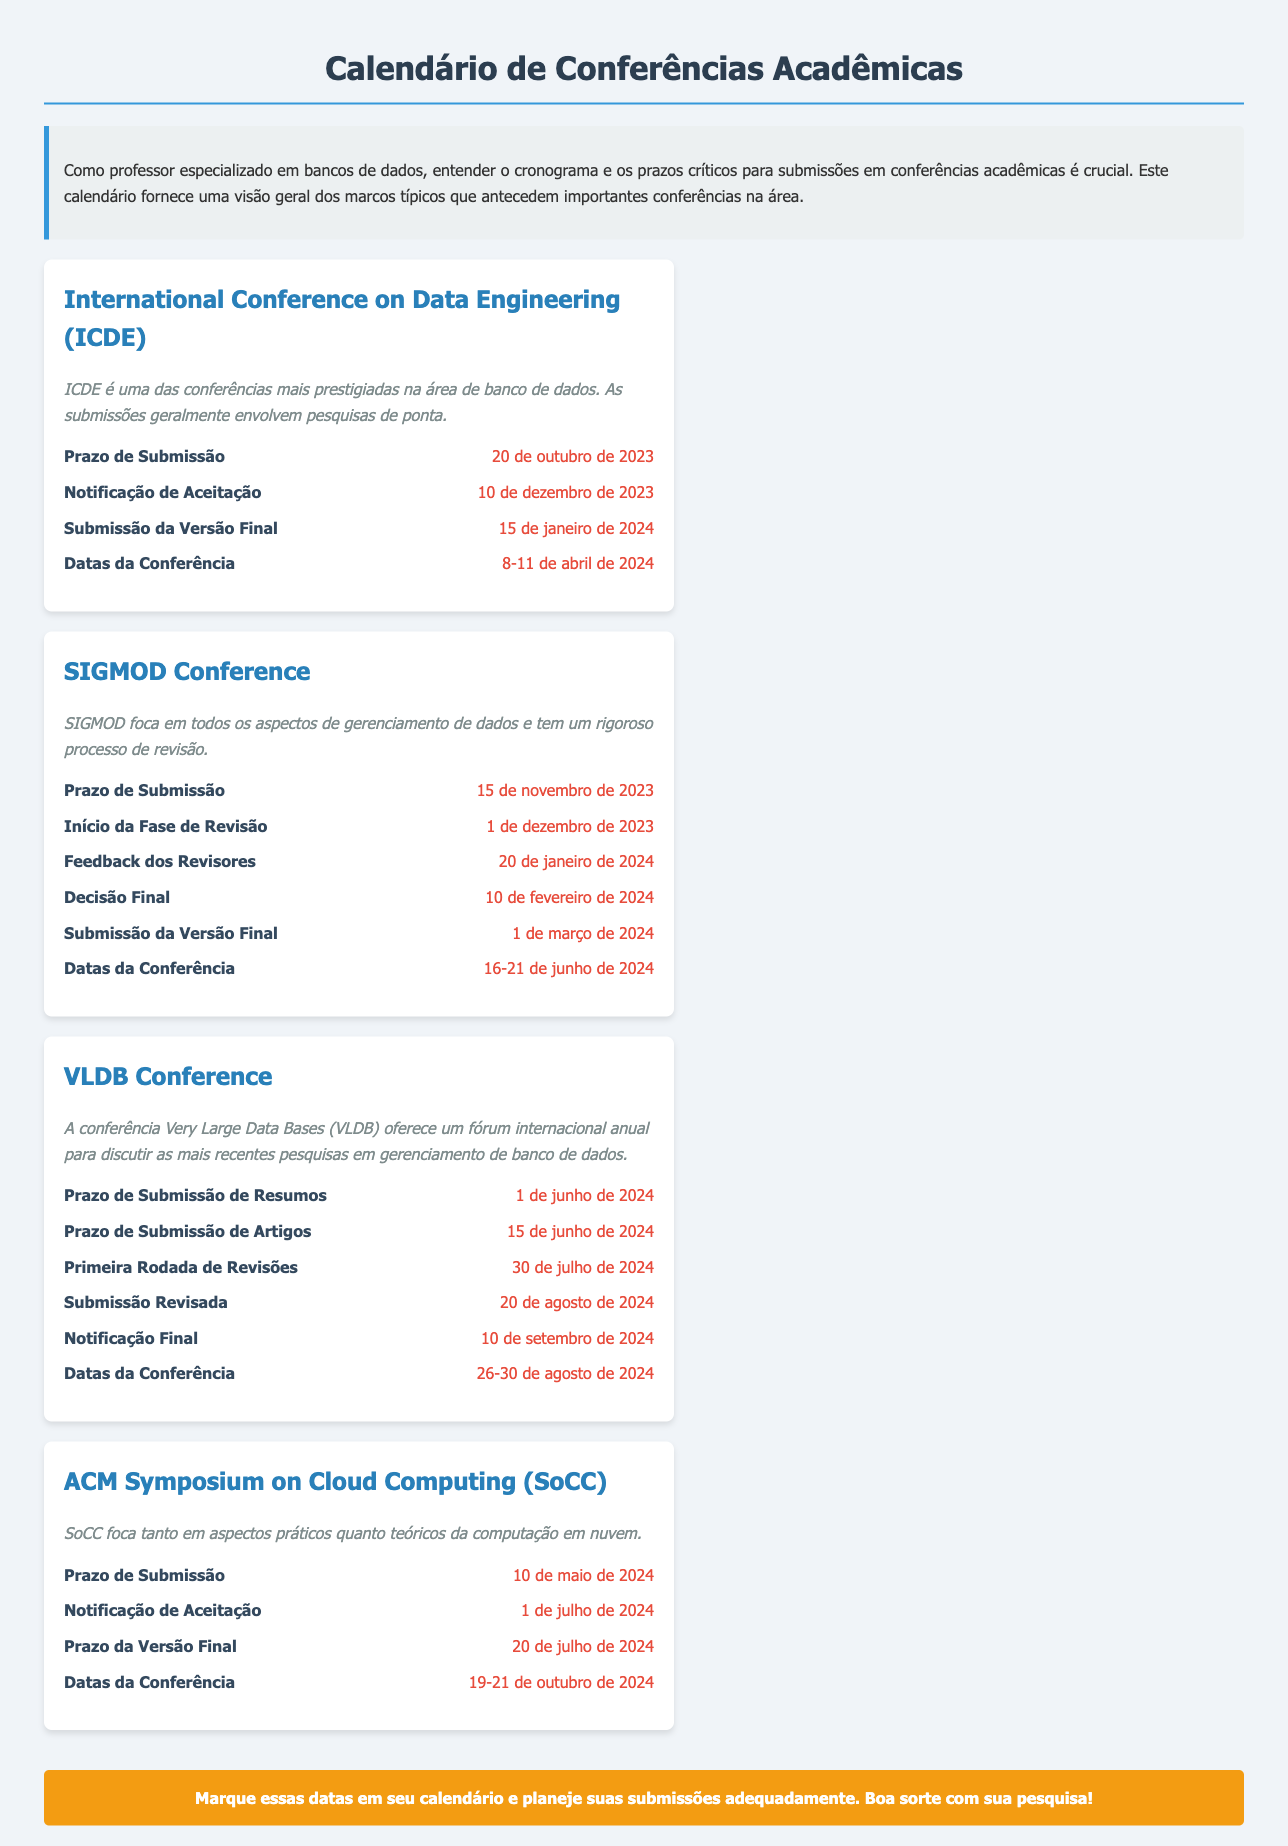qual é a data do prazo de submissão para a ICDE? O prazo de submissão para a ICDE está listado nas datas importantes da conferência.
Answer: 20 de outubro de 2023 quando a notificação de aceitação para a SIGMOD será divulgada? A notificação de aceitação para a SIGMOD está especificada nas datas importantes da conferência.
Answer: 10 de fevereiro de 2024 qual é o período das datas da conferência para VLDB? As datas da conferência VLDB são mencionadas na seção de datas importantes.
Answer: 26-30 de agosto de 2024 quando começa a fase de revisão para a SIGMOD? A fase de revisão da SIGMOD está informada nas datas importantes da conferência.
Answer: 1 de dezembro de 2023 qual é o prazo da versão final para a ACM SoCC? O prazo da versão final para a ACM SoCC é listado nas datas importantes da conferência.
Answer: 20 de julho de 2024 quanto tempo após o prazo de submissão a notificação de aceitação acontece para a ICDE? A notificação de aceitação para a ICDE ocorre após o prazo de submissão, conforme indicado nas datas relevantes.
Answer: Aproximadamente 50 dias qual conferência acontece primeiro, a ICDE ou a SIGMOD? É necessário comparar as datas das conferências indicadas no documento para determinar qual ocorre primeiro.
Answer: ICDE a que tipo de conferência foca a SIGMOD? O foco da SIGMOD é descrito na breve explicação sobre a conferência.
Answer: Gerenciamento de dados 